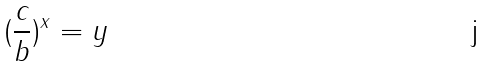<formula> <loc_0><loc_0><loc_500><loc_500>( \frac { c } { b } ) ^ { x } = y</formula> 